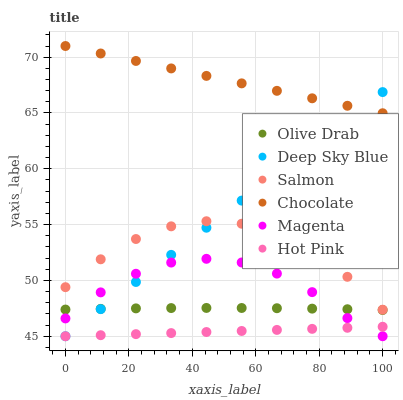Does Hot Pink have the minimum area under the curve?
Answer yes or no. Yes. Does Chocolate have the maximum area under the curve?
Answer yes or no. Yes. Does Salmon have the minimum area under the curve?
Answer yes or no. No. Does Salmon have the maximum area under the curve?
Answer yes or no. No. Is Deep Sky Blue the smoothest?
Answer yes or no. Yes. Is Salmon the roughest?
Answer yes or no. Yes. Is Chocolate the smoothest?
Answer yes or no. No. Is Chocolate the roughest?
Answer yes or no. No. Does Hot Pink have the lowest value?
Answer yes or no. Yes. Does Salmon have the lowest value?
Answer yes or no. No. Does Chocolate have the highest value?
Answer yes or no. Yes. Does Salmon have the highest value?
Answer yes or no. No. Is Olive Drab less than Salmon?
Answer yes or no. Yes. Is Salmon greater than Magenta?
Answer yes or no. Yes. Does Hot Pink intersect Magenta?
Answer yes or no. Yes. Is Hot Pink less than Magenta?
Answer yes or no. No. Is Hot Pink greater than Magenta?
Answer yes or no. No. Does Olive Drab intersect Salmon?
Answer yes or no. No. 